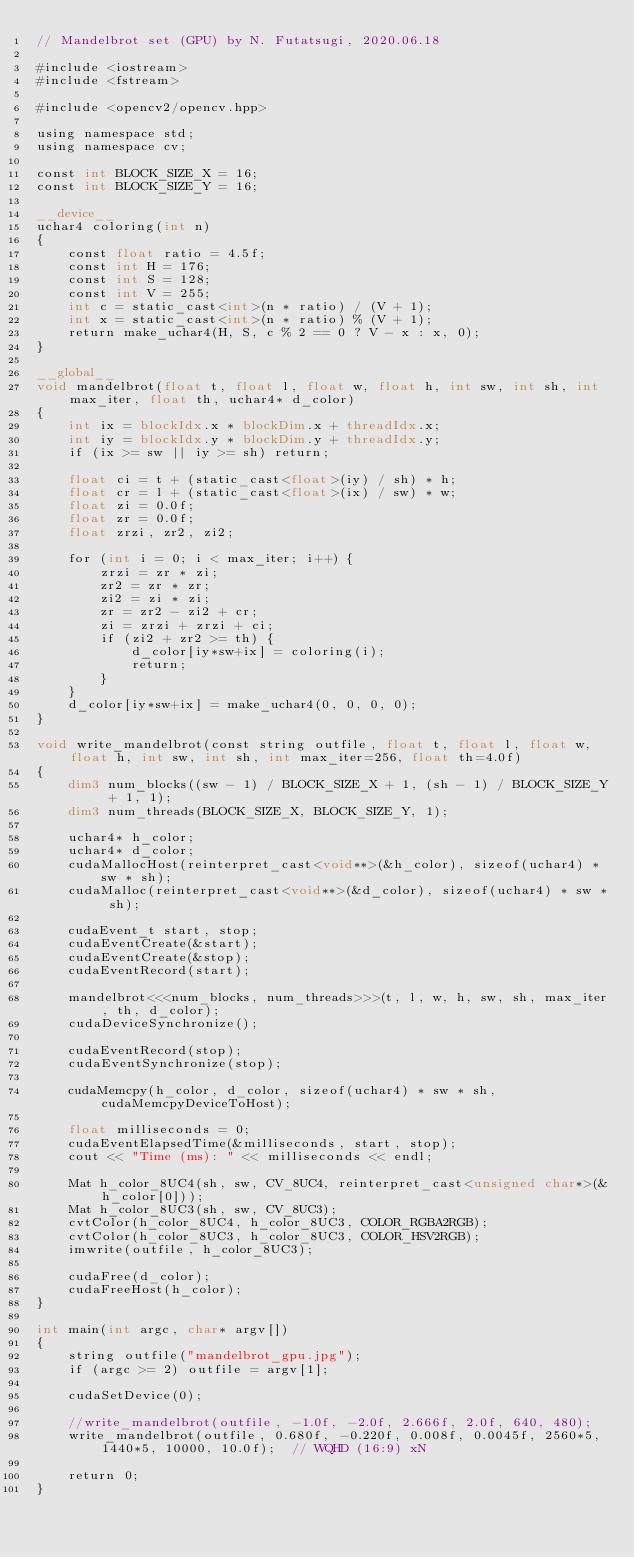<code> <loc_0><loc_0><loc_500><loc_500><_Cuda_>// Mandelbrot set (GPU) by N. Futatsugi, 2020.06.18

#include <iostream>
#include <fstream>

#include <opencv2/opencv.hpp>

using namespace std;
using namespace cv;

const int BLOCK_SIZE_X = 16;
const int BLOCK_SIZE_Y = 16;

__device__
uchar4 coloring(int n)
{
	const float ratio = 4.5f;
	const int H = 176;
	const int S = 128;
	const int V = 255;
	int c = static_cast<int>(n * ratio) / (V + 1);
	int x = static_cast<int>(n * ratio) % (V + 1);
	return make_uchar4(H, S, c % 2 == 0 ? V - x : x, 0);
}

__global__
void mandelbrot(float t, float l, float w, float h, int sw, int sh, int max_iter, float th, uchar4* d_color)
{
	int ix = blockIdx.x * blockDim.x + threadIdx.x;
	int iy = blockIdx.y * blockDim.y + threadIdx.y;
	if (ix >= sw || iy >= sh) return;

	float ci = t + (static_cast<float>(iy) / sh) * h;
	float cr = l + (static_cast<float>(ix) / sw) * w;
	float zi = 0.0f;
	float zr = 0.0f;
	float zrzi, zr2, zi2;

	for (int i = 0; i < max_iter; i++) {
		zrzi = zr * zi;
		zr2 = zr * zr;
		zi2 = zi * zi;
		zr = zr2 - zi2 + cr;
		zi = zrzi + zrzi + ci;
		if (zi2 + zr2 >= th) {
			d_color[iy*sw+ix] = coloring(i);
			return;
		}
	}
	d_color[iy*sw+ix] = make_uchar4(0, 0, 0, 0);
}

void write_mandelbrot(const string outfile, float t, float l, float w, float h, int sw, int sh, int max_iter=256, float th=4.0f)
{
	dim3 num_blocks((sw - 1) / BLOCK_SIZE_X + 1, (sh - 1) / BLOCK_SIZE_Y + 1, 1);
	dim3 num_threads(BLOCK_SIZE_X, BLOCK_SIZE_Y, 1);

	uchar4* h_color;
	uchar4* d_color;
	cudaMallocHost(reinterpret_cast<void**>(&h_color), sizeof(uchar4) * sw * sh);
	cudaMalloc(reinterpret_cast<void**>(&d_color), sizeof(uchar4) * sw * sh);

	cudaEvent_t start, stop;
	cudaEventCreate(&start);
	cudaEventCreate(&stop);
	cudaEventRecord(start);
	
	mandelbrot<<<num_blocks, num_threads>>>(t, l, w, h, sw, sh, max_iter, th, d_color);
	cudaDeviceSynchronize();

	cudaEventRecord(stop);
	cudaEventSynchronize(stop);

	cudaMemcpy(h_color, d_color, sizeof(uchar4) * sw * sh, cudaMemcpyDeviceToHost);

	float milliseconds = 0;
	cudaEventElapsedTime(&milliseconds, start, stop);
	cout << "Time (ms): " << milliseconds << endl;

	Mat h_color_8UC4(sh, sw, CV_8UC4, reinterpret_cast<unsigned char*>(&h_color[0]));
	Mat h_color_8UC3(sh, sw, CV_8UC3);
	cvtColor(h_color_8UC4, h_color_8UC3, COLOR_RGBA2RGB);
	cvtColor(h_color_8UC3, h_color_8UC3, COLOR_HSV2RGB);
	imwrite(outfile, h_color_8UC3);

	cudaFree(d_color);
	cudaFreeHost(h_color);
}

int main(int argc, char* argv[])
{
	string outfile("mandelbrot_gpu.jpg");
	if (argc >= 2) outfile = argv[1];

	cudaSetDevice(0);

	//write_mandelbrot(outfile, -1.0f, -2.0f, 2.666f, 2.0f, 640, 480);
	write_mandelbrot(outfile, 0.680f, -0.220f, 0.008f, 0.0045f, 2560*5, 1440*5, 10000, 10.0f);  // WQHD (16:9) xN

	return 0;
}
</code> 